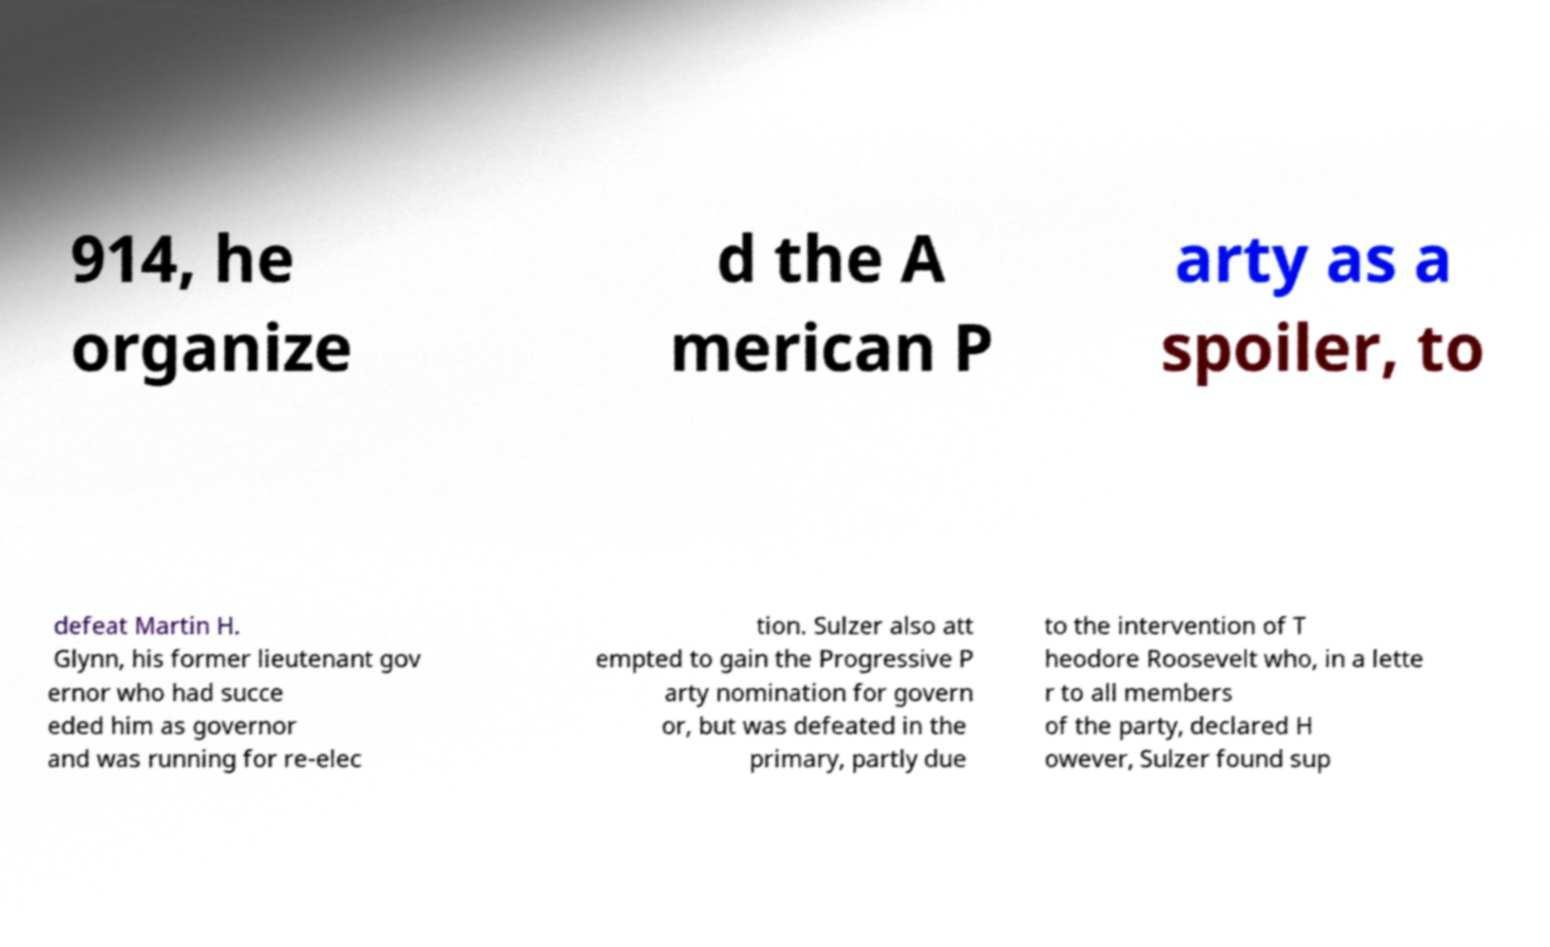Can you accurately transcribe the text from the provided image for me? 914, he organize d the A merican P arty as a spoiler, to defeat Martin H. Glynn, his former lieutenant gov ernor who had succe eded him as governor and was running for re-elec tion. Sulzer also att empted to gain the Progressive P arty nomination for govern or, but was defeated in the primary, partly due to the intervention of T heodore Roosevelt who, in a lette r to all members of the party, declared H owever, Sulzer found sup 